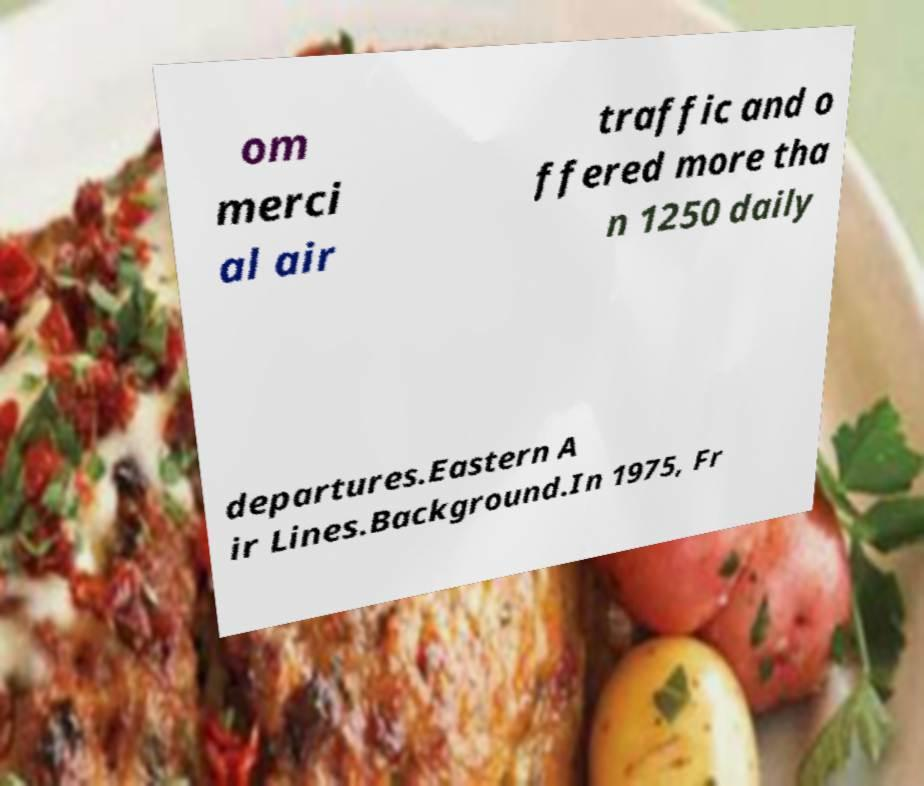Can you read and provide the text displayed in the image?This photo seems to have some interesting text. Can you extract and type it out for me? om merci al air traffic and o ffered more tha n 1250 daily departures.Eastern A ir Lines.Background.In 1975, Fr 